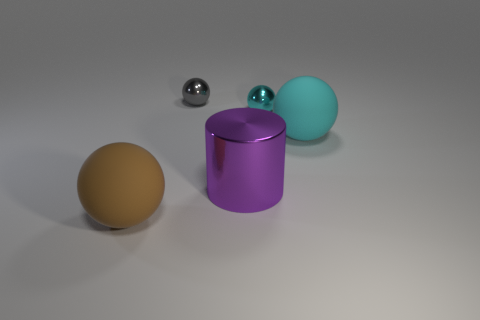Subtract all brown balls. How many balls are left? 3 Subtract all spheres. How many objects are left? 1 Add 5 brown rubber spheres. How many objects exist? 10 Subtract 1 cylinders. How many cylinders are left? 0 Subtract all metallic cylinders. Subtract all tiny cyan balls. How many objects are left? 3 Add 2 tiny gray objects. How many tiny gray objects are left? 3 Add 1 large yellow cylinders. How many large yellow cylinders exist? 1 Subtract all gray spheres. How many spheres are left? 3 Subtract 2 cyan balls. How many objects are left? 3 Subtract all blue spheres. Subtract all brown cylinders. How many spheres are left? 4 